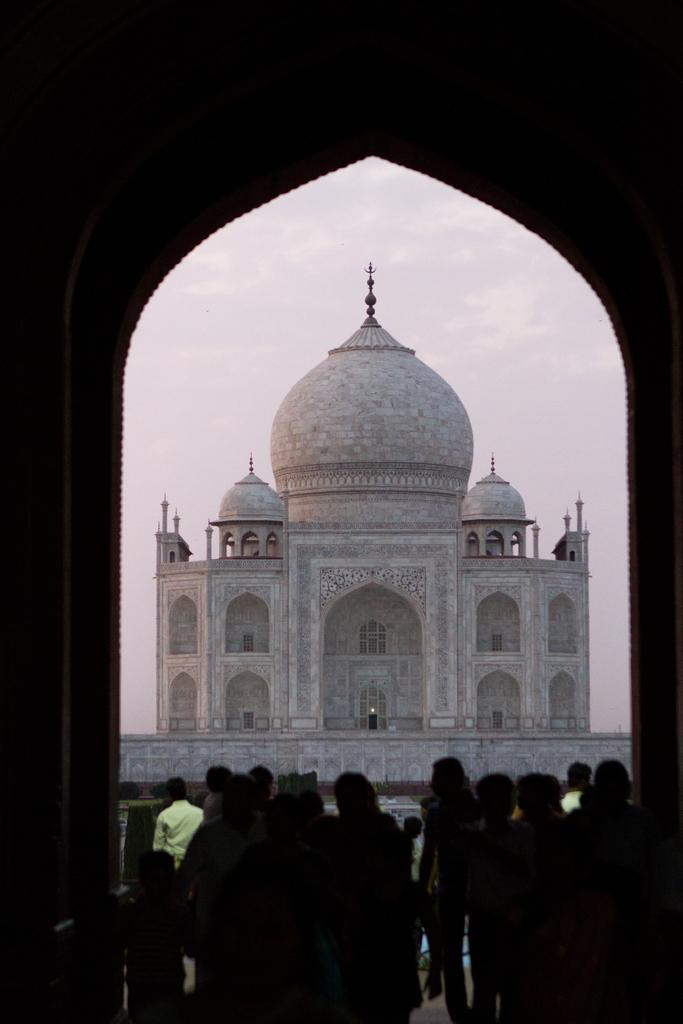What famous landmark is present in the image? The image contains the Taj Mahal. Are there any people in the image? Yes, there are people standing in the image. What can be seen in the background of the image? There is a sky visible in the background of the image. What type of oven can be seen in the image? There is no oven present in the image. Can you see a monkey climbing the Taj Mahal in the image? No, there are no monkeys visible in the image. 